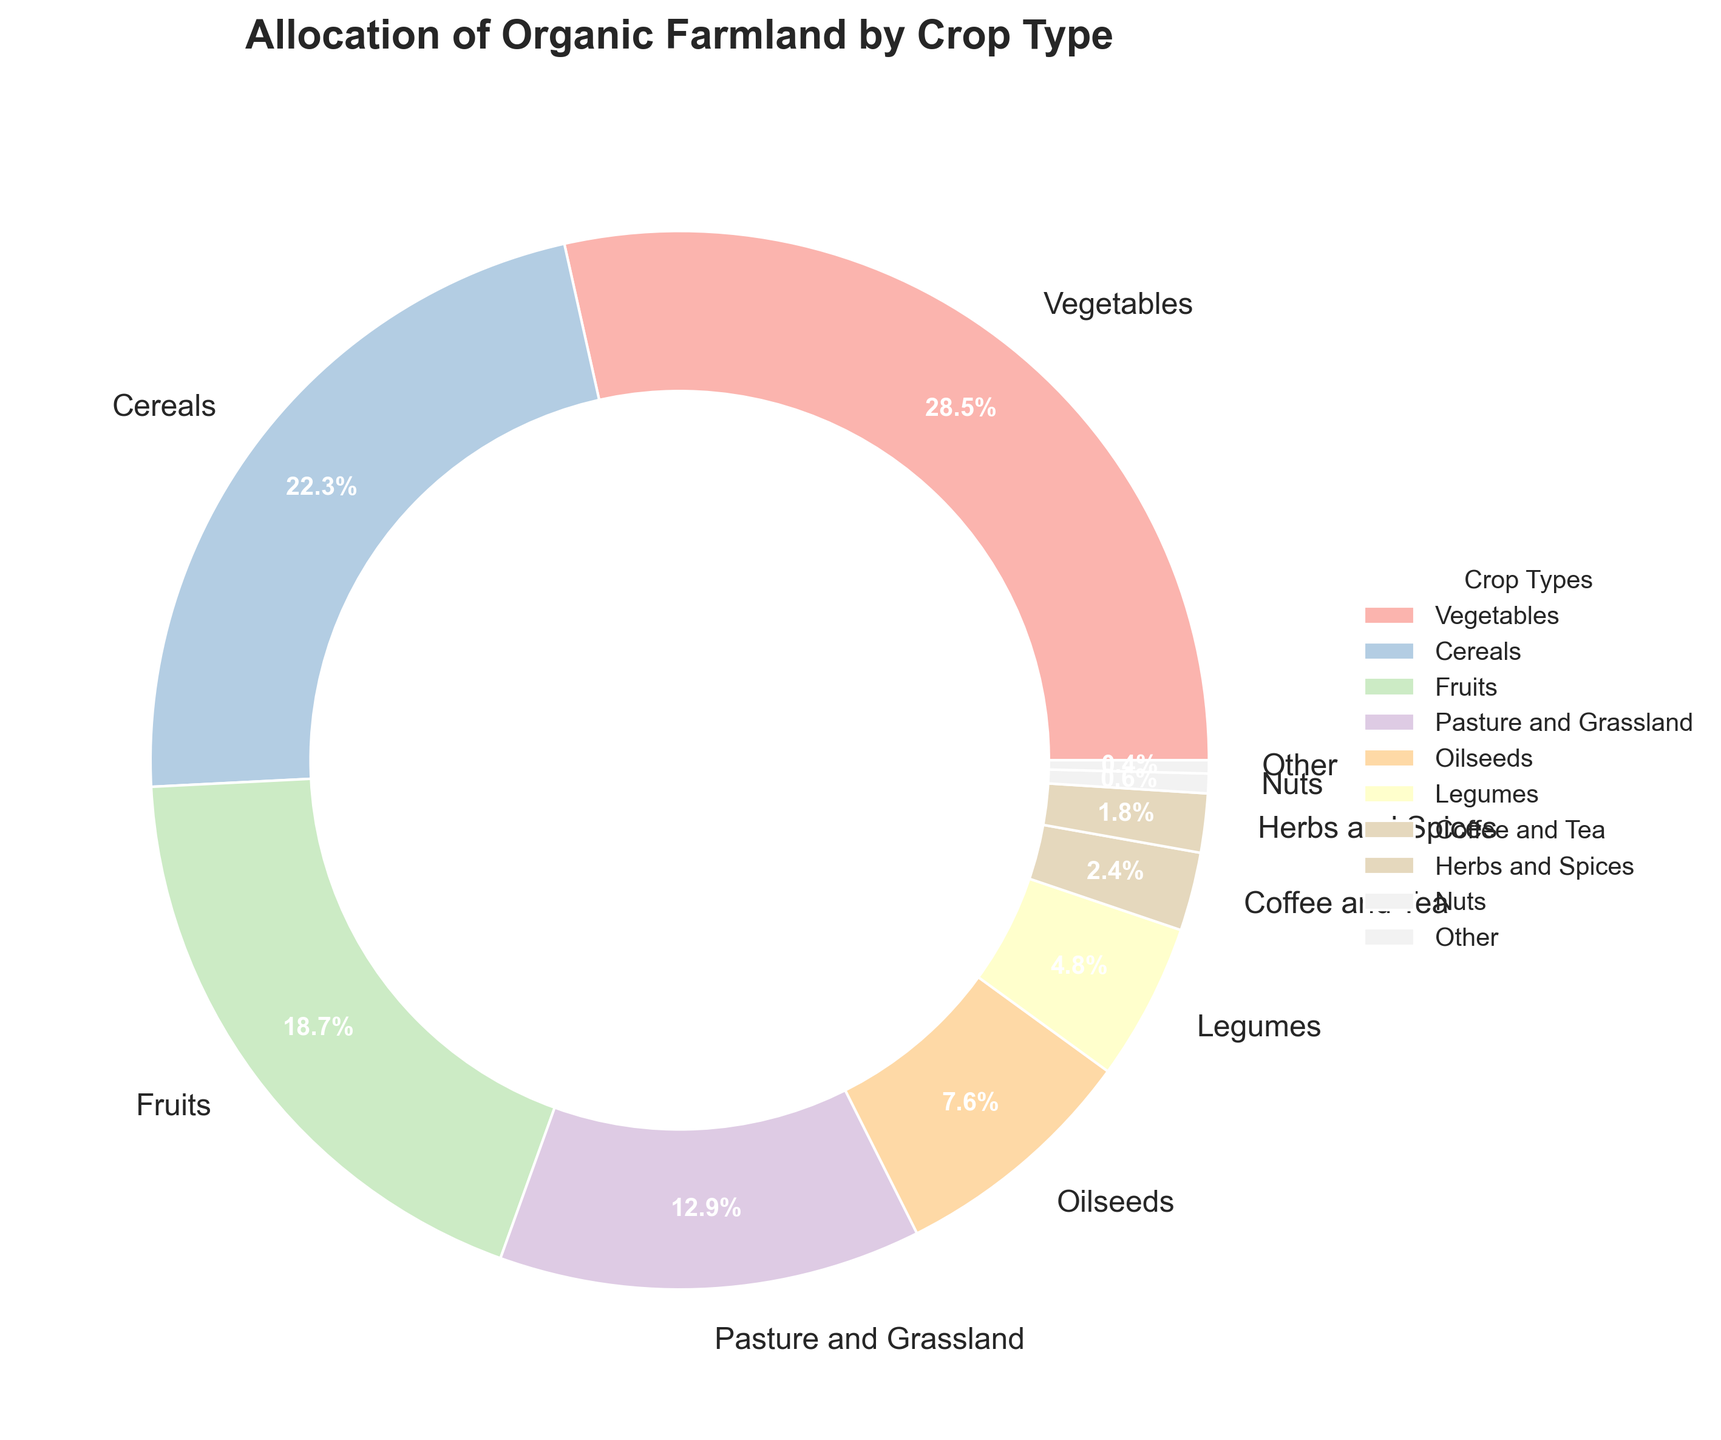What crop type occupies the largest percentage of organic farmland? The largest slice of the pie chart corresponds to Vegetables, which has the largest percentage of organic farmland at 28.5%.
Answer: Vegetables Which crop type represents the smallest portion of the organic farmland? The smallest slice in the pie chart corresponds to Nuts, which occupies 0.6% of the organic farmland.
Answer: Nuts What is the combined percentage of organic farmland allocated to Fruits and Cereals? To find the combined percentage, add the percentages for Fruits and Cereals: 18.7% (Fruits) + 22.3% (Cereals) = 41%.
Answer: 41% Which is allocated more organic farmland: Oilseeds or Legumes? By comparing the percentages, Oilseeds have 7.6% and Legumes have 4.8%. Therefore, Oilseeds occupy more organic farmland.
Answer: Oilseeds What's the difference in percentage allocation between Vegetables and Pasture and Grassland? The difference is calculated as 28.5% (Vegetables) - 12.9% (Pasture and Grassland) = 15.6%.
Answer: 15.6% Is the percentage of organic farmland allocated to Coffee and Tea greater than Herbs and Spices? The percentage for Coffee and Tea is 2.4%, whereas for Herbs and Spices it is 1.8%. Therefore, Coffee and Tea has a greater percentage.
Answer: Yes Combine the percentage allocation for Nuts, Herbs and Spices, and Other. What is the total? Add the percentages for Nuts (0.6%), Herbs and Spices (1.8%), and Other (0.4%): 0.6% + 1.8% + 0.4% = 2.8%.
Answer: 2.8% How much more organic farmland is allocated to Vegetables compared to Oilseeds? The difference is 28.5% (Vegetables) - 7.6% (Oilseeds) = 20.9%.
Answer: 20.9% Arrange the top three crop types by their percentage allocation. The top three crop types in descending order of their percentages are Vegetables (28.5%), Cereals (22.3%), and Fruits (18.7%).
Answer: Vegetables, Cereals, Fruits What is the average percentage of organic farmland allocated to Fruits, Coffee and Tea, and Herbs and Spices? Calculate the average by adding the percentages and dividing by the number of crop types: (18.7% + 2.4% + 1.8%) / 3 = 7.63%.
Answer: 7.63% 